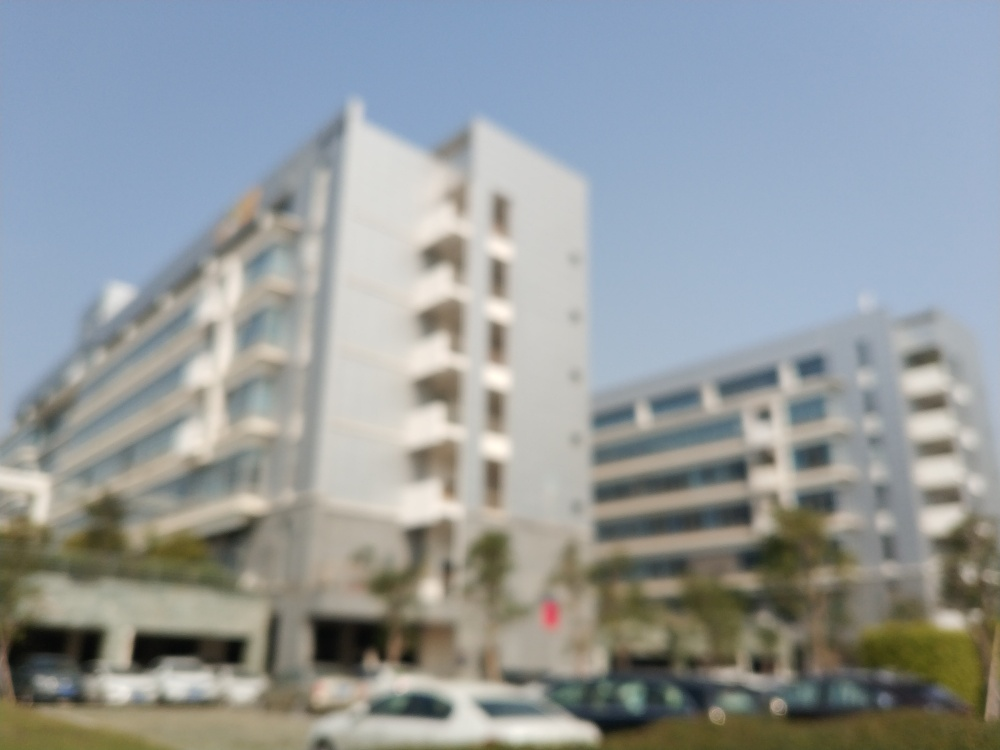Can you tell what kind of buildings are in the image? The buildings appear to be multi-story, likely office buildings or apartments, but due to the image being out of focus, specific details are not discernible. 